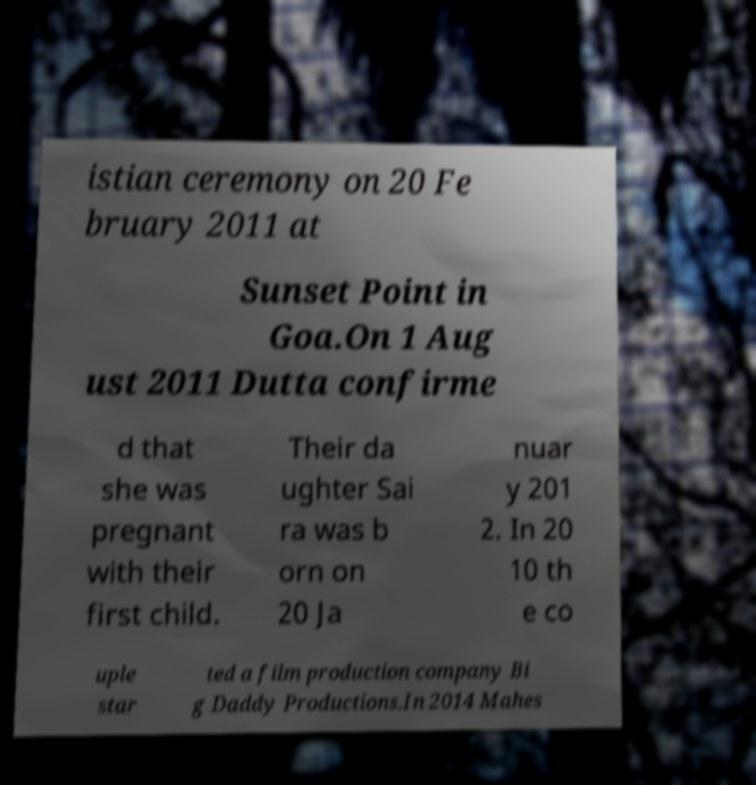Could you extract and type out the text from this image? istian ceremony on 20 Fe bruary 2011 at Sunset Point in Goa.On 1 Aug ust 2011 Dutta confirme d that she was pregnant with their first child. Their da ughter Sai ra was b orn on 20 Ja nuar y 201 2. In 20 10 th e co uple star ted a film production company Bi g Daddy Productions.In 2014 Mahes 